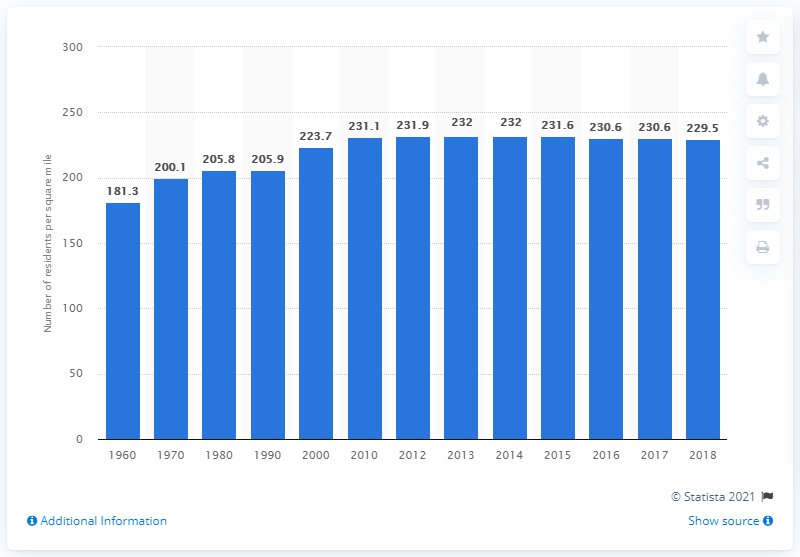Identify some key points in this picture. The population density per square mile of land in the state of Illinois in 2018 was 229.5 people per square mile. 